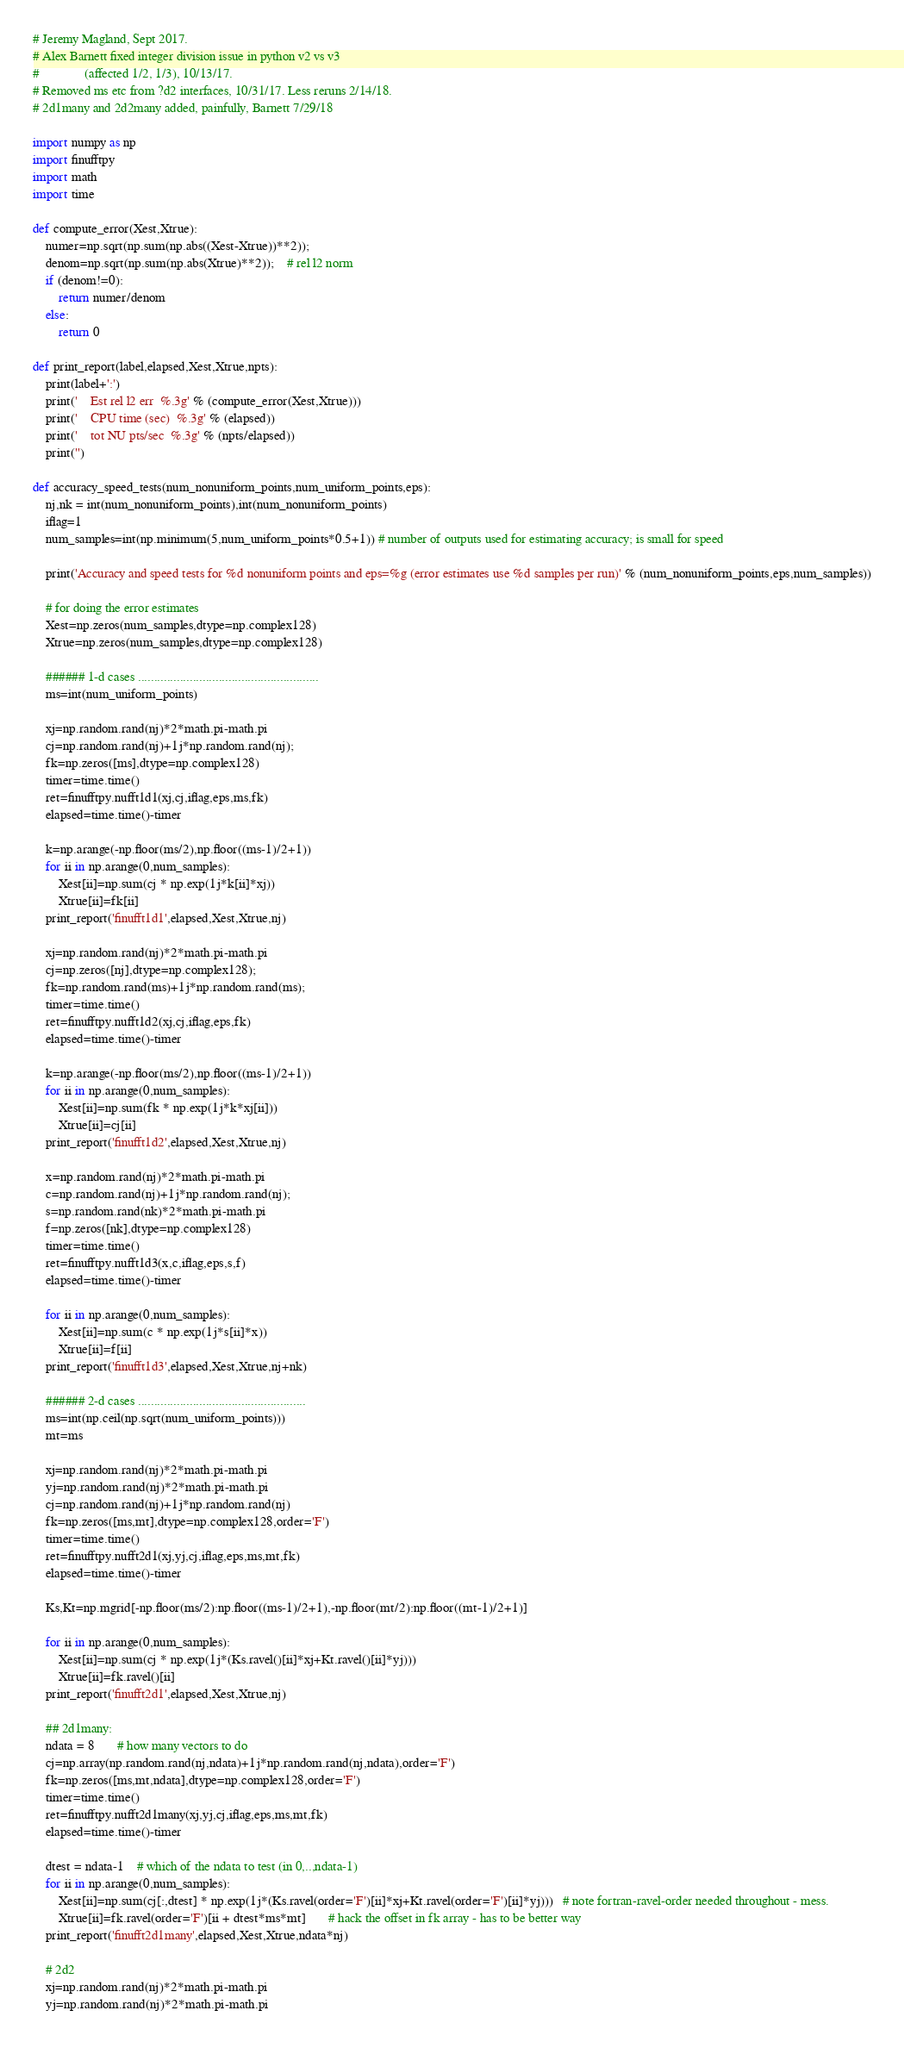Convert code to text. <code><loc_0><loc_0><loc_500><loc_500><_Python_># Jeremy Magland, Sept 2017.
# Alex Barnett fixed integer division issue in python v2 vs v3
#              (affected 1/2, 1/3), 10/13/17.
# Removed ms etc from ?d2 interfaces, 10/31/17. Less reruns 2/14/18.
# 2d1many and 2d2many added, painfully, Barnett 7/29/18

import numpy as np
import finufftpy
import math
import time

def compute_error(Xest,Xtrue):
	numer=np.sqrt(np.sum(np.abs((Xest-Xtrue))**2));
	denom=np.sqrt(np.sum(np.abs(Xtrue)**2));    # rel l2 norm
	if (denom!=0):
		return numer/denom
	else:
		return 0

def print_report(label,elapsed,Xest,Xtrue,npts):
	print(label+':')
	print('    Est rel l2 err  %.3g' % (compute_error(Xest,Xtrue)))
	print('    CPU time (sec)  %.3g' % (elapsed))
	print('    tot NU pts/sec  %.3g' % (npts/elapsed))
	print('')

def accuracy_speed_tests(num_nonuniform_points,num_uniform_points,eps):
	nj,nk = int(num_nonuniform_points),int(num_nonuniform_points)
	iflag=1
	num_samples=int(np.minimum(5,num_uniform_points*0.5+1)) # number of outputs used for estimating accuracy; is small for speed

	print('Accuracy and speed tests for %d nonuniform points and eps=%g (error estimates use %d samples per run)' % (num_nonuniform_points,eps,num_samples))

	# for doing the error estimates
	Xest=np.zeros(num_samples,dtype=np.complex128)
	Xtrue=np.zeros(num_samples,dtype=np.complex128)

	###### 1-d cases ........................................................
	ms=int(num_uniform_points)

	xj=np.random.rand(nj)*2*math.pi-math.pi
	cj=np.random.rand(nj)+1j*np.random.rand(nj);
	fk=np.zeros([ms],dtype=np.complex128)
	timer=time.time()
	ret=finufftpy.nufft1d1(xj,cj,iflag,eps,ms,fk)
	elapsed=time.time()-timer

	k=np.arange(-np.floor(ms/2),np.floor((ms-1)/2+1))
	for ii in np.arange(0,num_samples):
		Xest[ii]=np.sum(cj * np.exp(1j*k[ii]*xj))
		Xtrue[ii]=fk[ii]
	print_report('finufft1d1',elapsed,Xest,Xtrue,nj)

	xj=np.random.rand(nj)*2*math.pi-math.pi
	cj=np.zeros([nj],dtype=np.complex128);
	fk=np.random.rand(ms)+1j*np.random.rand(ms);
	timer=time.time()
	ret=finufftpy.nufft1d2(xj,cj,iflag,eps,fk)
	elapsed=time.time()-timer

	k=np.arange(-np.floor(ms/2),np.floor((ms-1)/2+1))
	for ii in np.arange(0,num_samples):
		Xest[ii]=np.sum(fk * np.exp(1j*k*xj[ii]))
		Xtrue[ii]=cj[ii]
	print_report('finufft1d2',elapsed,Xest,Xtrue,nj)

	x=np.random.rand(nj)*2*math.pi-math.pi
	c=np.random.rand(nj)+1j*np.random.rand(nj);
	s=np.random.rand(nk)*2*math.pi-math.pi
	f=np.zeros([nk],dtype=np.complex128)
	timer=time.time()
	ret=finufftpy.nufft1d3(x,c,iflag,eps,s,f)
	elapsed=time.time()-timer

	for ii in np.arange(0,num_samples):
		Xest[ii]=np.sum(c * np.exp(1j*s[ii]*x))
		Xtrue[ii]=f[ii]
	print_report('finufft1d3',elapsed,Xest,Xtrue,nj+nk)

	###### 2-d cases ....................................................
	ms=int(np.ceil(np.sqrt(num_uniform_points)))
	mt=ms

	xj=np.random.rand(nj)*2*math.pi-math.pi
	yj=np.random.rand(nj)*2*math.pi-math.pi
	cj=np.random.rand(nj)+1j*np.random.rand(nj)
	fk=np.zeros([ms,mt],dtype=np.complex128,order='F')
	timer=time.time()
	ret=finufftpy.nufft2d1(xj,yj,cj,iflag,eps,ms,mt,fk)
	elapsed=time.time()-timer

	Ks,Kt=np.mgrid[-np.floor(ms/2):np.floor((ms-1)/2+1),-np.floor(mt/2):np.floor((mt-1)/2+1)]

	for ii in np.arange(0,num_samples):
		Xest[ii]=np.sum(cj * np.exp(1j*(Ks.ravel()[ii]*xj+Kt.ravel()[ii]*yj)))
		Xtrue[ii]=fk.ravel()[ii]
	print_report('finufft2d1',elapsed,Xest,Xtrue,nj)

	## 2d1many:
	ndata = 8       # how many vectors to do
	cj=np.array(np.random.rand(nj,ndata)+1j*np.random.rand(nj,ndata),order='F')
	fk=np.zeros([ms,mt,ndata],dtype=np.complex128,order='F')
	timer=time.time()
	ret=finufftpy.nufft2d1many(xj,yj,cj,iflag,eps,ms,mt,fk)
	elapsed=time.time()-timer

	dtest = ndata-1    # which of the ndata to test (in 0,..,ndata-1)
	for ii in np.arange(0,num_samples):
		Xest[ii]=np.sum(cj[:,dtest] * np.exp(1j*(Ks.ravel(order='F')[ii]*xj+Kt.ravel(order='F')[ii]*yj)))   # note fortran-ravel-order needed throughout - mess.
		Xtrue[ii]=fk.ravel(order='F')[ii + dtest*ms*mt]       # hack the offset in fk array - has to be better way
	print_report('finufft2d1many',elapsed,Xest,Xtrue,ndata*nj)

	# 2d2
	xj=np.random.rand(nj)*2*math.pi-math.pi
	yj=np.random.rand(nj)*2*math.pi-math.pi</code> 